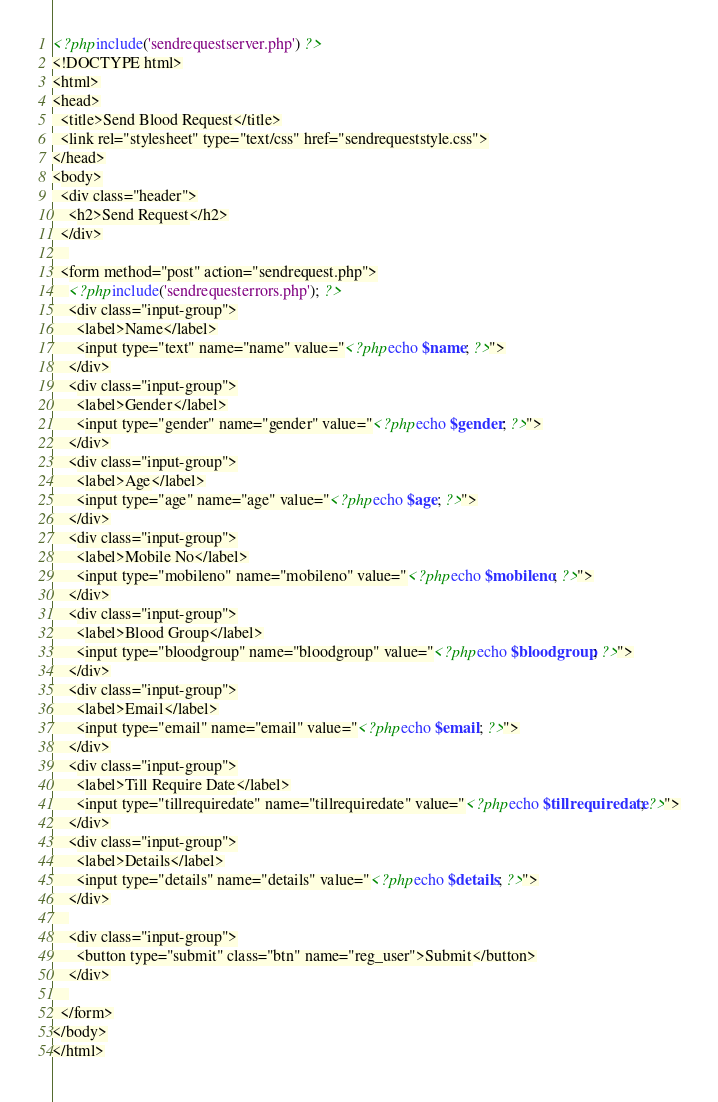Convert code to text. <code><loc_0><loc_0><loc_500><loc_500><_PHP_><?php include('sendrequestserver.php') ?>
<!DOCTYPE html>
<html>
<head>
  <title>Send Blood Request</title>
  <link rel="stylesheet" type="text/css" href="sendrequeststyle.css">
</head>
<body>
  <div class="header">
  	<h2>Send Request</h2>
  </div>
	
  <form method="post" action="sendrequest.php">
  	<?php include('sendrequesterrors.php'); ?>
  	<div class="input-group">
  	  <label>Name</label>
  	  <input type="text" name="name" value="<?php echo $name; ?>">
  	</div>
	<div class="input-group">
  	  <label>Gender</label>
  	  <input type="gender" name="gender" value="<?php echo $gender; ?>">
  	</div>
	<div class="input-group">
  	  <label>Age</label>
  	  <input type="age" name="age" value="<?php echo $age; ?>">
  	</div>
	<div class="input-group">
  	  <label>Mobile No</label>
  	  <input type="mobileno" name="mobileno" value="<?php echo $mobileno; ?>">
  	</div>
	<div class="input-group">
  	  <label>Blood Group</label>
  	  <input type="bloodgroup" name="bloodgroup" value="<?php echo $bloodgroup; ?>">
  	</div>
  	<div class="input-group">
  	  <label>Email</label>
  	  <input type="email" name="email" value="<?php echo $email; ?>">
  	</div>
	<div class="input-group">
  	  <label>Till Require Date</label>
  	  <input type="tillrequiredate" name="tillrequiredate" value="<?php echo $tillrequiredate; ?>">
  	</div>
	<div class="input-group">
  	  <label>Details</label>
  	  <input type="details" name="details" value="<?php echo $details; ?>">
  	</div>
  	
  	<div class="input-group">
  	  <button type="submit" class="btn" name="reg_user">Submit</button>
  	</div>
  	
  </form>
</body>
</html></code> 